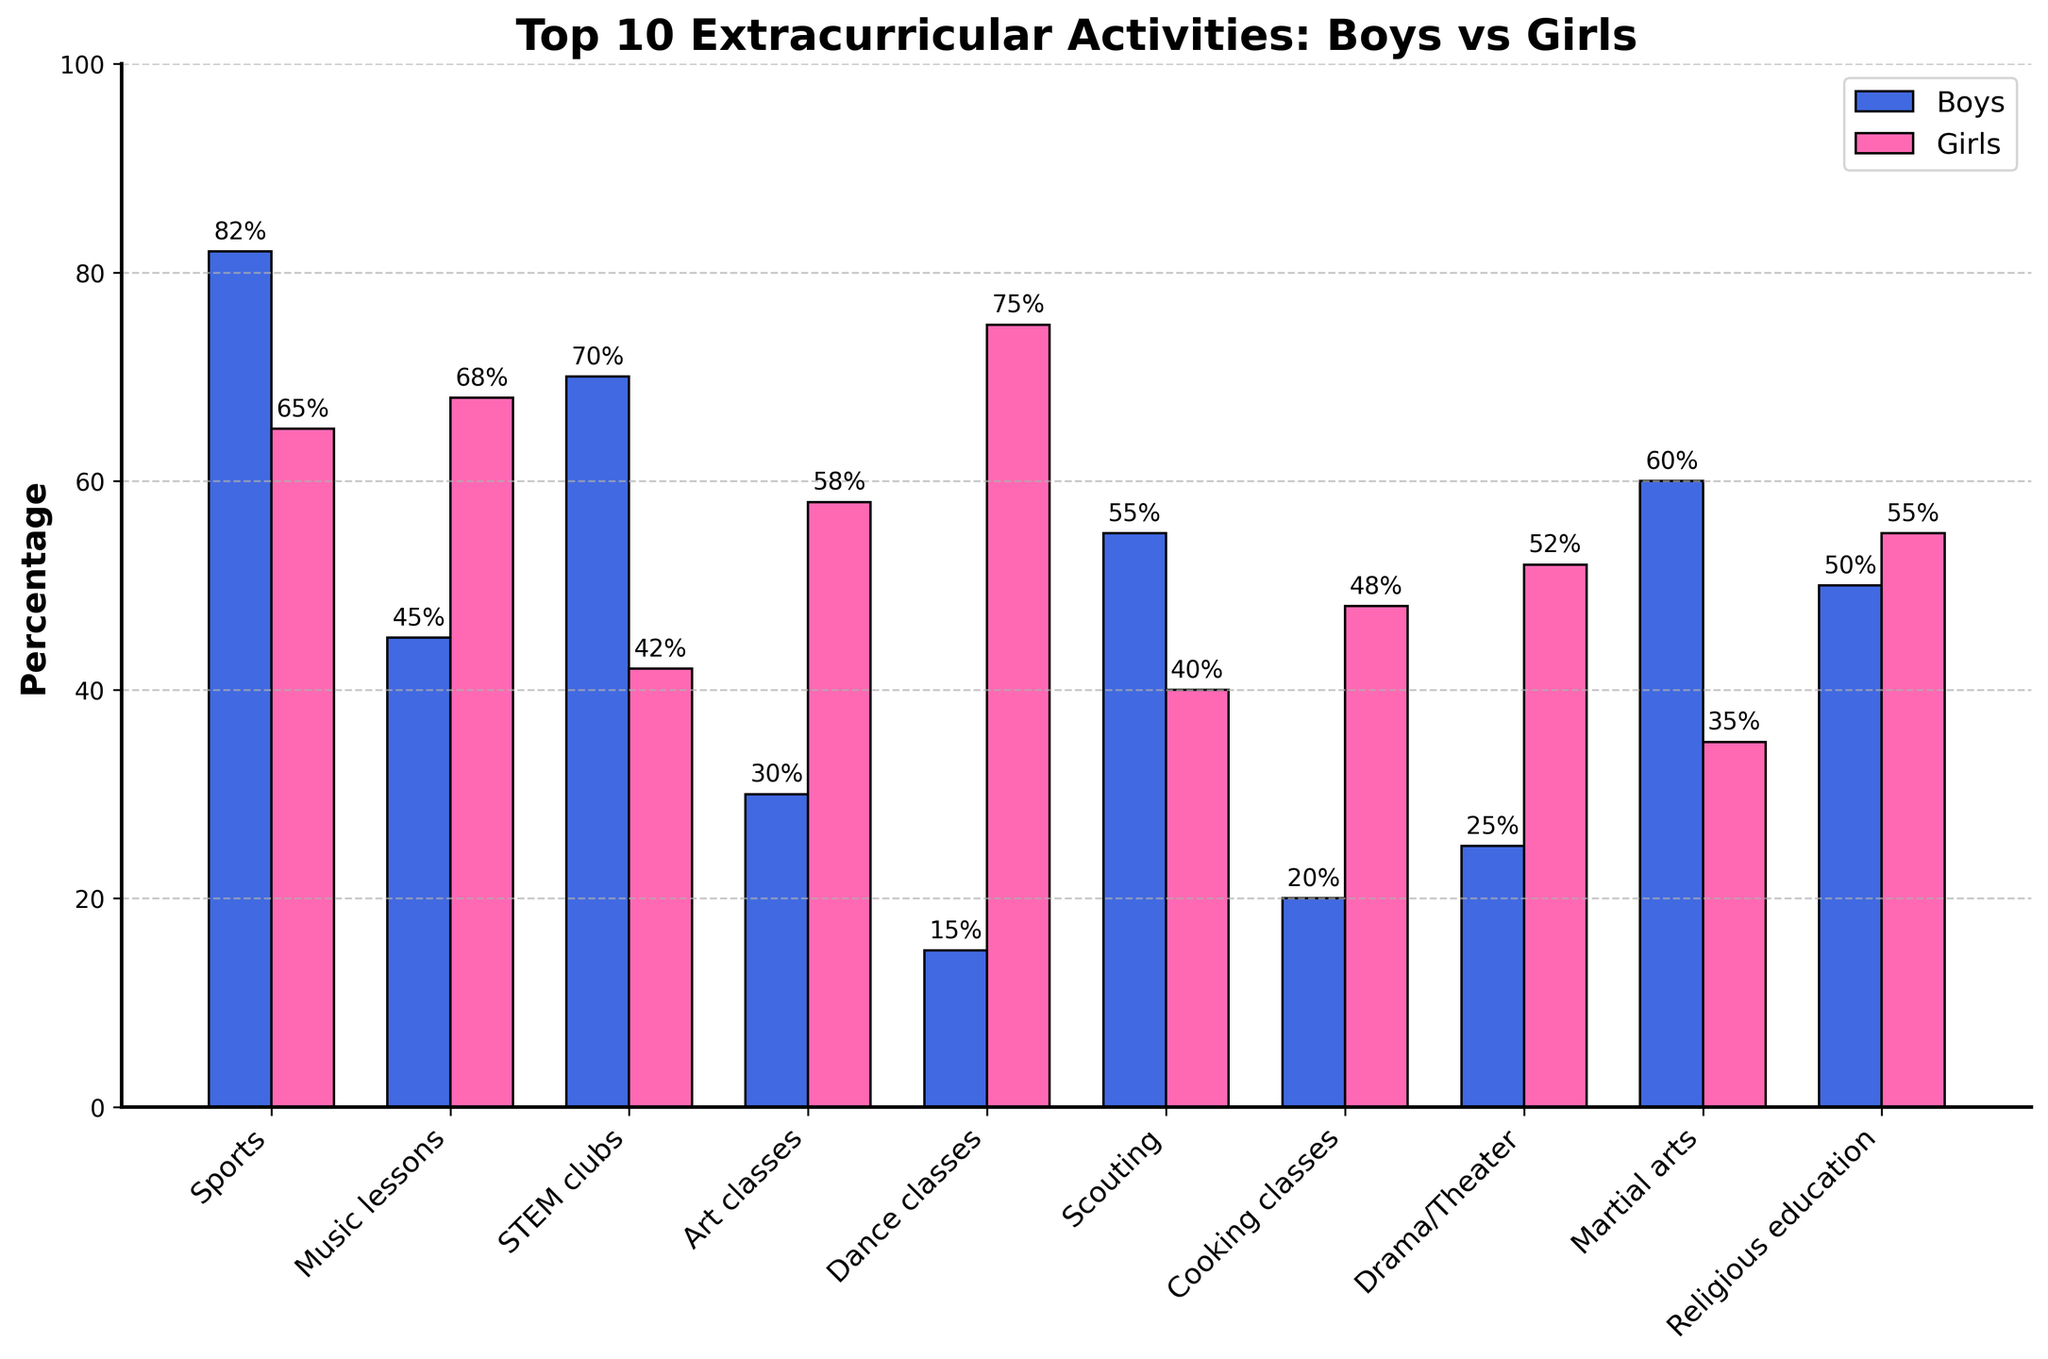Which activity has the highest percentage for boys? The activity with the highest bar for boys is Sports, which reaches 82%.
Answer: Sports Which extracurricular activity do girls participate in the most? For girls, the highest bar corresponds to Dance classes, reaching 75%.
Answer: Dance classes What is the total percentage of boys in Music lessons and STEM clubs? Music lessons have 45% boys, and STEM clubs have 70%. Adding them together: 45% + 70% = 115%.
Answer: 115% How does the participation in Art classes compare between boys and girls? The percentage for boys in Art classes is 30%, while for girls it is 58%. So, girls have a 28% higher participation in Art classes compared to boys.
Answer: Girls participate 28% more Which activity has a larger gender gap in favor of girls? The largest disparity favoring girls is in Dance classes, where 75% of girls participate compared to only 15% of boys. The difference is 75% - 15% = 60%.
Answer: Dance classes Are there any activities where boys and girls participate approximately equally? The subjects with nearly equal bars are Religious education: boys at 50% and girls at 55%, making a 5% difference.
Answer: Religious education Which visual attribute signifies the data for boys in the bar chart? The bars representing boys are filled with a blue color.
Answer: Blue color bars What is the combined percentage for both boys and girls participating in Scouting? The percentage participation in Scouting is 55% for boys and 40% for girls. Adding them gives: 55% + 40% = 95%.
Answer: 95% How does participation in Cooking classes differ between boys and girls? Boys participate in Cooking classes at 20%, while girls participate at 48%, indicating a 28% higher participation rate for girls.
Answer: Girls participate 28% more Which gender has a higher percentage in Music lessons, and by how much? Girls participate more in Music lessons at 68%, compared to boys at 45%. The difference is 68% - 45% = 23%.
Answer: Girls by 23% 